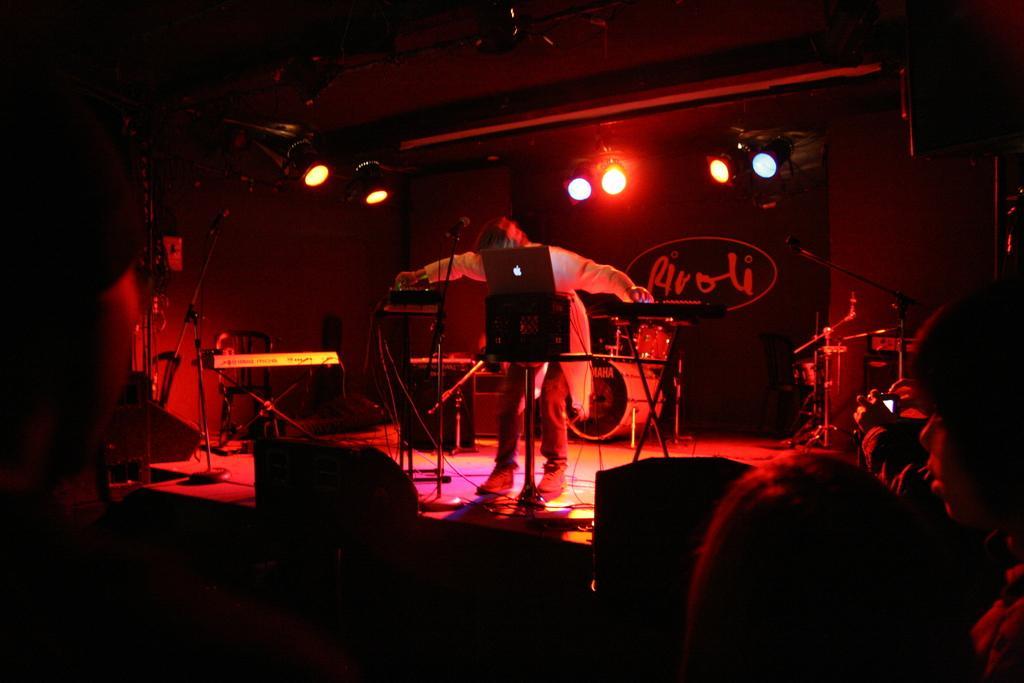Could you give a brief overview of what you see in this image? In this picture we can see a group of people, one person is standing on the stage, another person is holding a camera, here we can see musical instruments, lights, banner, wall and some objects. 